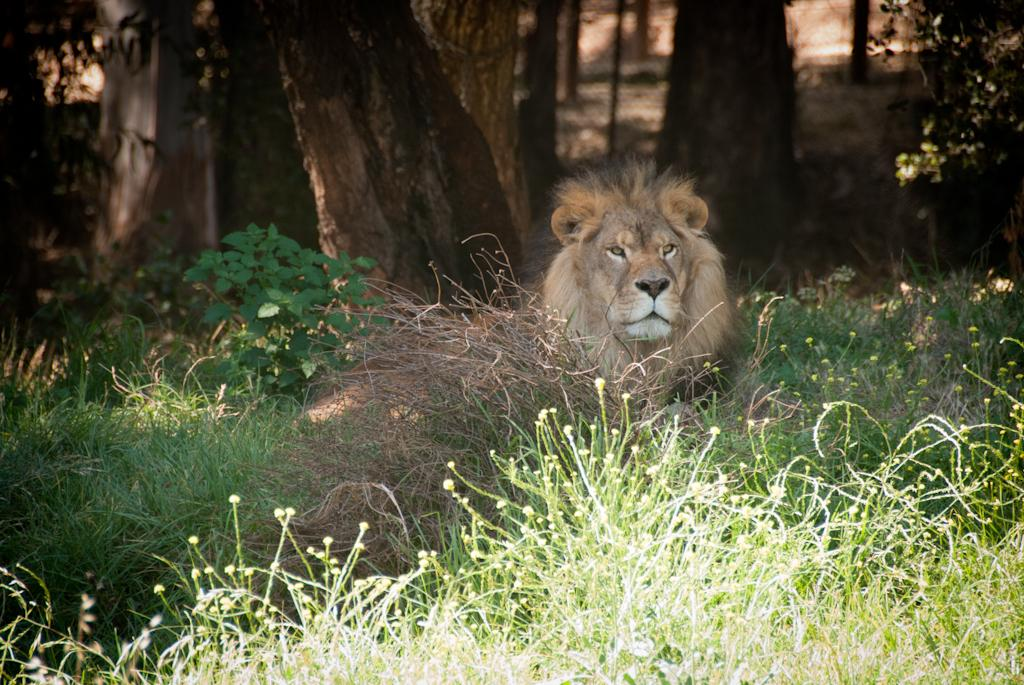What can be observed about the background of the image? The background of the image is blurry. What type of structure can be seen in the image? A fence is visible in the image. What type of natural elements are present in the image? There are tree trunks, plants, and twigs in the image. What type of animal is present in the image? A lion is present in the image. Can you see any hens laying eggs in the image? There are no hens or eggs present in the image. Is there a volcano erupting in the background of the image? There is no volcano present in the image, and no eruption is depicted. 